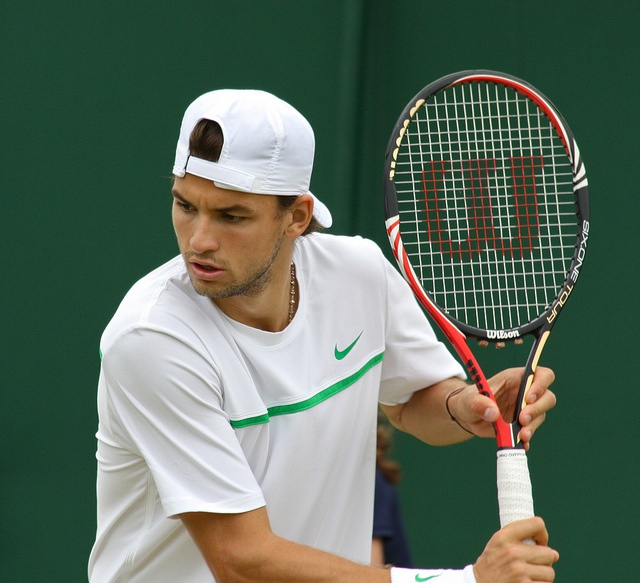Describe the objects in this image and their specific colors. I can see people in darkgreen, lightgray, darkgray, gray, and brown tones, tennis racket in darkgreen, black, ivory, and gray tones, and people in darkgreen, black, and maroon tones in this image. 